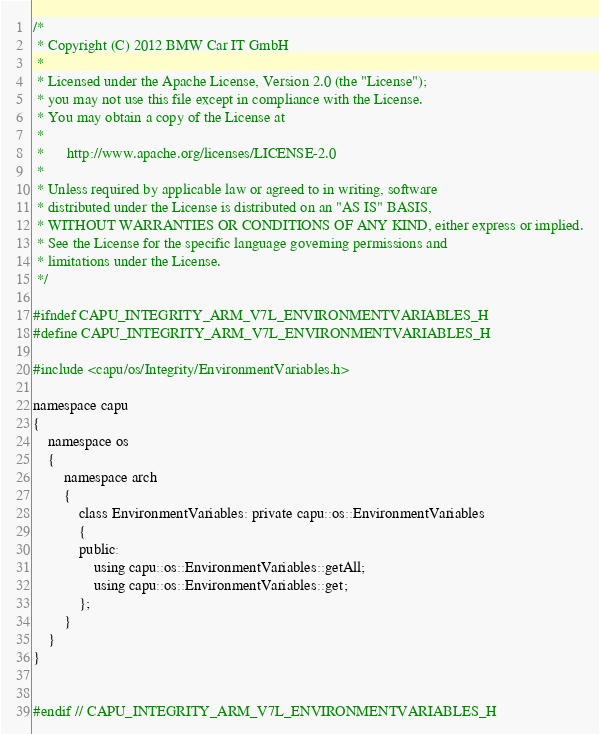Convert code to text. <code><loc_0><loc_0><loc_500><loc_500><_C_>/*
 * Copyright (C) 2012 BMW Car IT GmbH
 *
 * Licensed under the Apache License, Version 2.0 (the "License");
 * you may not use this file except in compliance with the License.
 * You may obtain a copy of the License at
 *
 *      http://www.apache.org/licenses/LICENSE-2.0
 *
 * Unless required by applicable law or agreed to in writing, software
 * distributed under the License is distributed on an "AS IS" BASIS,
 * WITHOUT WARRANTIES OR CONDITIONS OF ANY KIND, either express or implied.
 * See the License for the specific language governing permissions and
 * limitations under the License.
 */

#ifndef CAPU_INTEGRITY_ARM_V7L_ENVIRONMENTVARIABLES_H
#define CAPU_INTEGRITY_ARM_V7L_ENVIRONMENTVARIABLES_H

#include <capu/os/Integrity/EnvironmentVariables.h>

namespace capu
{
    namespace os
    {
        namespace arch
        {
            class EnvironmentVariables: private capu::os::EnvironmentVariables
            {
            public:
                using capu::os::EnvironmentVariables::getAll;
                using capu::os::EnvironmentVariables::get;
            };
        }
    }
}


#endif // CAPU_INTEGRITY_ARM_V7L_ENVIRONMENTVARIABLES_H
</code> 